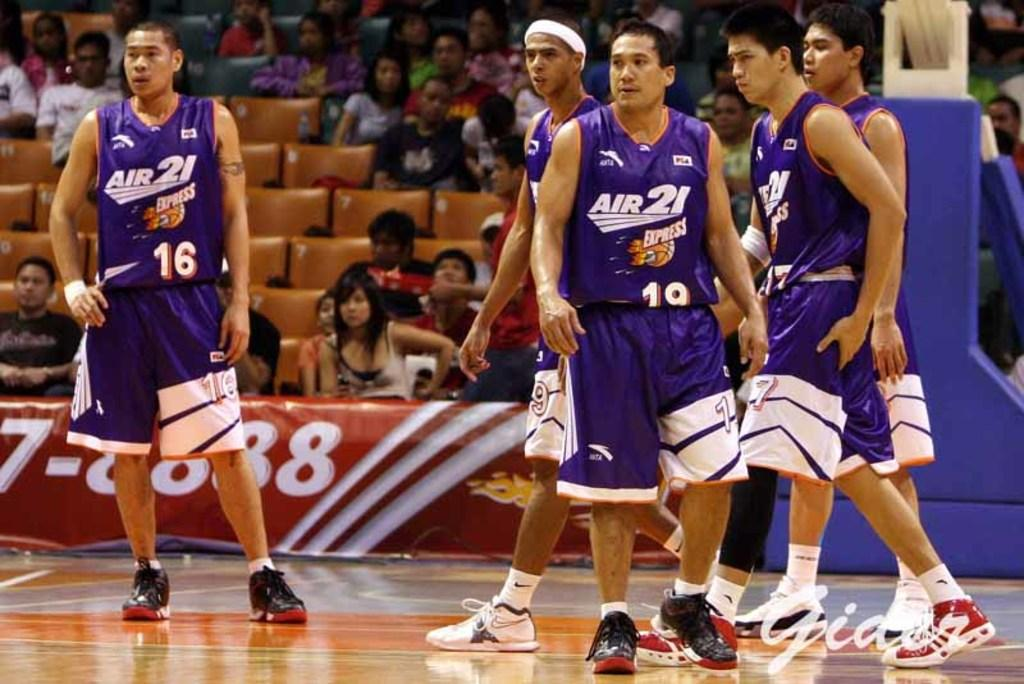<image>
Offer a succinct explanation of the picture presented. Five basketball players are wearing purple Air 21 branded uniforms. 